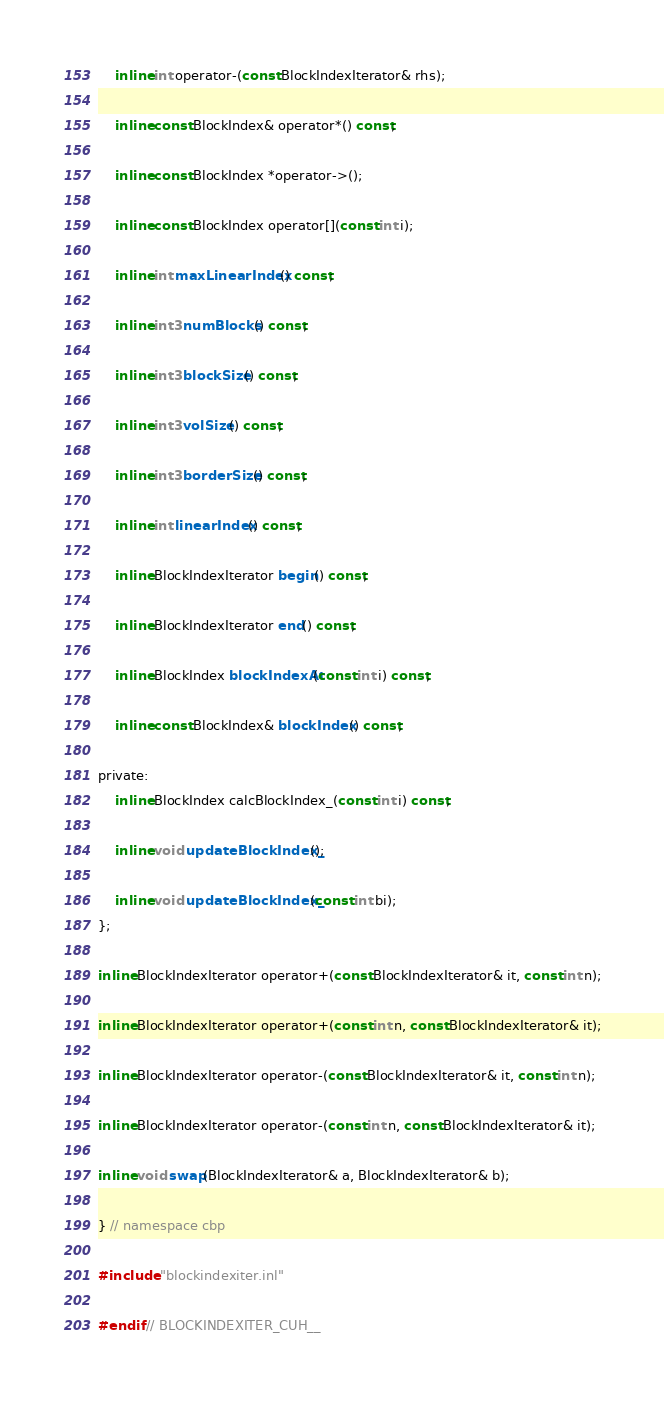<code> <loc_0><loc_0><loc_500><loc_500><_Cuda_>
    inline int operator-(const BlockIndexIterator& rhs);

    inline const BlockIndex& operator*() const;

    inline const BlockIndex *operator->();

    inline const BlockIndex operator[](const int i);

    inline int maxLinearIndex() const;

    inline int3 numBlocks() const;

    inline int3 blockSize() const;

    inline int3 volSize() const;

    inline int3 borderSize() const;

    inline int linearIndex() const;

    inline BlockIndexIterator begin() const;

    inline BlockIndexIterator end() const;

    inline BlockIndex blockIndexAt(const int i) const;

    inline const BlockIndex& blockIndex() const;

private:
    inline BlockIndex calcBlockIndex_(const int i) const;

    inline void updateBlockIndex_();

    inline void updateBlockIndex_(const int bi);
};

inline BlockIndexIterator operator+(const BlockIndexIterator& it, const int n);

inline BlockIndexIterator operator+(const int n, const BlockIndexIterator& it);

inline BlockIndexIterator operator-(const BlockIndexIterator& it, const int n);

inline BlockIndexIterator operator-(const int n, const BlockIndexIterator& it);

inline void swap(BlockIndexIterator& a, BlockIndexIterator& b);

} // namespace cbp

#include "blockindexiter.inl"

#endif // BLOCKINDEXITER_CUH__</code> 